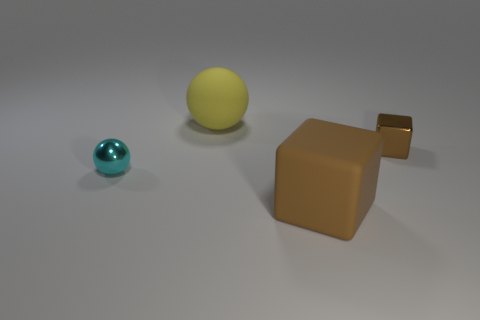Do the brown cube that is in front of the shiny ball and the large yellow thing have the same size?
Your answer should be very brief. Yes. What is the size of the metallic block?
Ensure brevity in your answer.  Small. There is a tiny metal thing to the right of the sphere that is left of the large yellow rubber sphere that is behind the big brown rubber block; what color is it?
Offer a terse response. Brown. Do the cube that is behind the brown matte block and the big cube have the same color?
Provide a succinct answer. Yes. How many objects are in front of the large yellow rubber object and to the right of the cyan object?
Your response must be concise. 2. What is the size of the rubber thing that is the same shape as the cyan shiny object?
Provide a short and direct response. Large. What number of objects are in front of the brown thing on the left side of the metal object that is on the right side of the small ball?
Your answer should be compact. 0. What color is the object behind the cube that is behind the large brown rubber cube?
Offer a terse response. Yellow. How many other things are made of the same material as the large ball?
Your response must be concise. 1. There is a brown cube that is to the right of the big brown cube; how many big matte things are in front of it?
Make the answer very short. 1. 